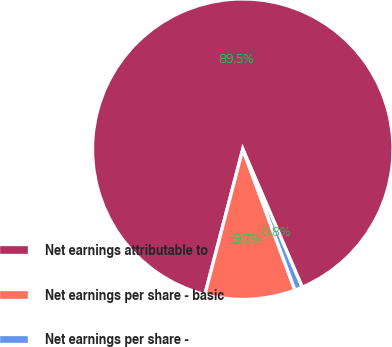Convert chart to OTSL. <chart><loc_0><loc_0><loc_500><loc_500><pie_chart><fcel>Net earnings attributable to<fcel>Net earnings per share - basic<fcel>Net earnings per share -<nl><fcel>89.47%<fcel>9.7%<fcel>0.83%<nl></chart> 